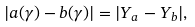<formula> <loc_0><loc_0><loc_500><loc_500>| a ( \gamma ) - b ( \gamma ) | = | Y _ { a } - Y _ { b } | ,</formula> 